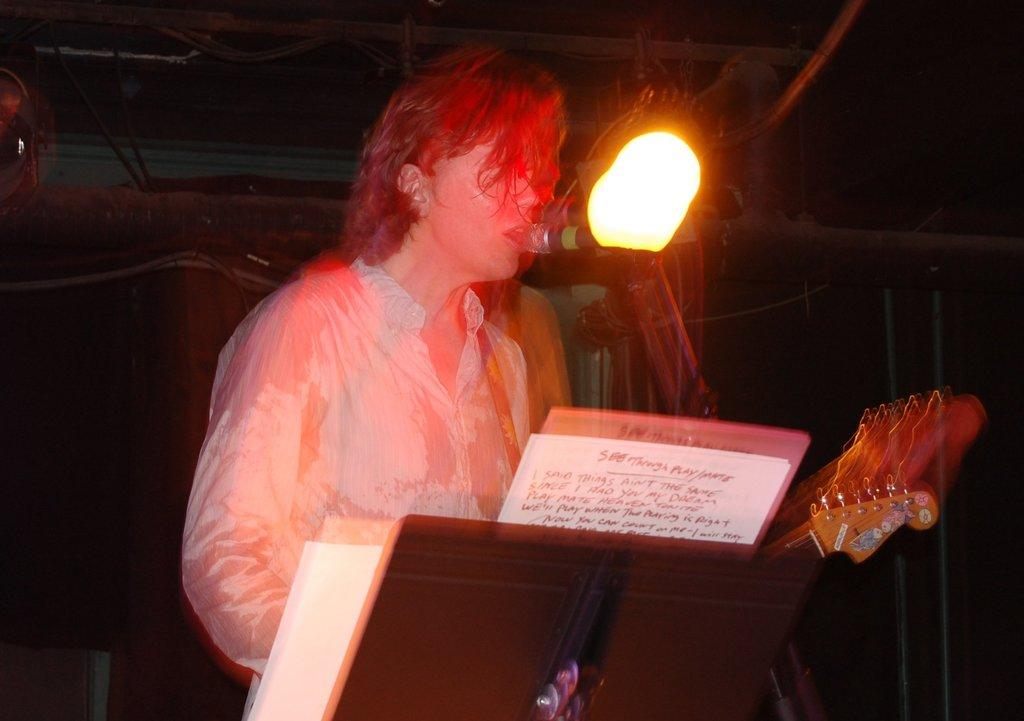What is the person in the image doing? The person is standing at the desk in the image. What is the person holding in the image? The person is holding a guitar. What can be seen on the desk in the image? There are papers on the desk. What is visible in the background of the image? There are lights and a wall visible in the background. What type of coat is draped over the guitar in the image? There is no coat present in the image; the person is holding a guitar. 